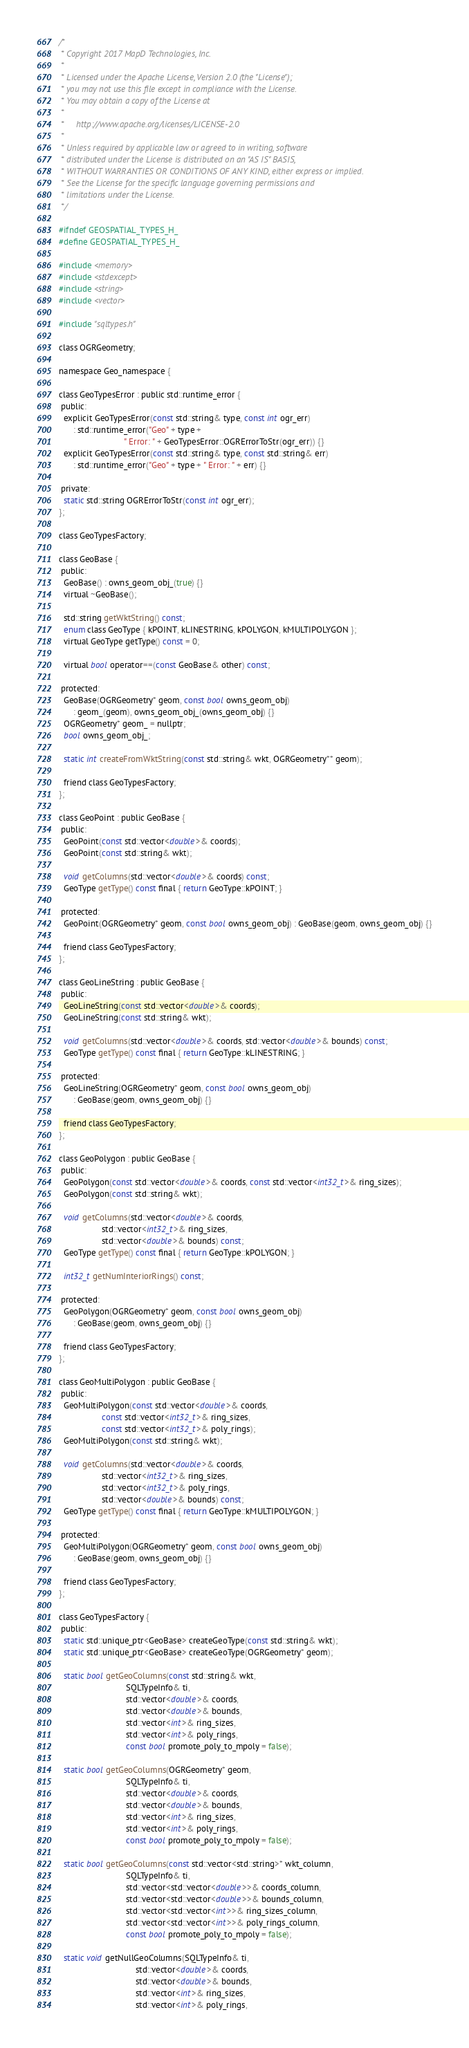<code> <loc_0><loc_0><loc_500><loc_500><_C_>/*
 * Copyright 2017 MapD Technologies, Inc.
 *
 * Licensed under the Apache License, Version 2.0 (the "License");
 * you may not use this file except in compliance with the License.
 * You may obtain a copy of the License at
 *
 *     http://www.apache.org/licenses/LICENSE-2.0
 *
 * Unless required by applicable law or agreed to in writing, software
 * distributed under the License is distributed on an "AS IS" BASIS,
 * WITHOUT WARRANTIES OR CONDITIONS OF ANY KIND, either express or implied.
 * See the License for the specific language governing permissions and
 * limitations under the License.
 */

#ifndef GEOSPATIAL_TYPES_H_
#define GEOSPATIAL_TYPES_H_

#include <memory>
#include <stdexcept>
#include <string>
#include <vector>

#include "sqltypes.h"

class OGRGeometry;

namespace Geo_namespace {

class GeoTypesError : public std::runtime_error {
 public:
  explicit GeoTypesError(const std::string& type, const int ogr_err)
      : std::runtime_error("Geo" + type +
                           " Error: " + GeoTypesError::OGRErrorToStr(ogr_err)) {}
  explicit GeoTypesError(const std::string& type, const std::string& err)
      : std::runtime_error("Geo" + type + " Error: " + err) {}

 private:
  static std::string OGRErrorToStr(const int ogr_err);
};

class GeoTypesFactory;

class GeoBase {
 public:
  GeoBase() : owns_geom_obj_(true) {}
  virtual ~GeoBase();

  std::string getWktString() const;
  enum class GeoType { kPOINT, kLINESTRING, kPOLYGON, kMULTIPOLYGON };
  virtual GeoType getType() const = 0;

  virtual bool operator==(const GeoBase& other) const;

 protected:
  GeoBase(OGRGeometry* geom, const bool owns_geom_obj)
      : geom_(geom), owns_geom_obj_(owns_geom_obj) {}
  OGRGeometry* geom_ = nullptr;
  bool owns_geom_obj_;

  static int createFromWktString(const std::string& wkt, OGRGeometry** geom);

  friend class GeoTypesFactory;
};

class GeoPoint : public GeoBase {
 public:
  GeoPoint(const std::vector<double>& coords);
  GeoPoint(const std::string& wkt);

  void getColumns(std::vector<double>& coords) const;
  GeoType getType() const final { return GeoType::kPOINT; }

 protected:
  GeoPoint(OGRGeometry* geom, const bool owns_geom_obj) : GeoBase(geom, owns_geom_obj) {}

  friend class GeoTypesFactory;
};

class GeoLineString : public GeoBase {
 public:
  GeoLineString(const std::vector<double>& coords);
  GeoLineString(const std::string& wkt);

  void getColumns(std::vector<double>& coords, std::vector<double>& bounds) const;
  GeoType getType() const final { return GeoType::kLINESTRING; }

 protected:
  GeoLineString(OGRGeometry* geom, const bool owns_geom_obj)
      : GeoBase(geom, owns_geom_obj) {}

  friend class GeoTypesFactory;
};

class GeoPolygon : public GeoBase {
 public:
  GeoPolygon(const std::vector<double>& coords, const std::vector<int32_t>& ring_sizes);
  GeoPolygon(const std::string& wkt);

  void getColumns(std::vector<double>& coords,
                  std::vector<int32_t>& ring_sizes,
                  std::vector<double>& bounds) const;
  GeoType getType() const final { return GeoType::kPOLYGON; }

  int32_t getNumInteriorRings() const;

 protected:
  GeoPolygon(OGRGeometry* geom, const bool owns_geom_obj)
      : GeoBase(geom, owns_geom_obj) {}

  friend class GeoTypesFactory;
};

class GeoMultiPolygon : public GeoBase {
 public:
  GeoMultiPolygon(const std::vector<double>& coords,
                  const std::vector<int32_t>& ring_sizes,
                  const std::vector<int32_t>& poly_rings);
  GeoMultiPolygon(const std::string& wkt);

  void getColumns(std::vector<double>& coords,
                  std::vector<int32_t>& ring_sizes,
                  std::vector<int32_t>& poly_rings,
                  std::vector<double>& bounds) const;
  GeoType getType() const final { return GeoType::kMULTIPOLYGON; }

 protected:
  GeoMultiPolygon(OGRGeometry* geom, const bool owns_geom_obj)
      : GeoBase(geom, owns_geom_obj) {}

  friend class GeoTypesFactory;
};

class GeoTypesFactory {
 public:
  static std::unique_ptr<GeoBase> createGeoType(const std::string& wkt);
  static std::unique_ptr<GeoBase> createGeoType(OGRGeometry* geom);

  static bool getGeoColumns(const std::string& wkt,
                            SQLTypeInfo& ti,
                            std::vector<double>& coords,
                            std::vector<double>& bounds,
                            std::vector<int>& ring_sizes,
                            std::vector<int>& poly_rings,
                            const bool promote_poly_to_mpoly = false);

  static bool getGeoColumns(OGRGeometry* geom,
                            SQLTypeInfo& ti,
                            std::vector<double>& coords,
                            std::vector<double>& bounds,
                            std::vector<int>& ring_sizes,
                            std::vector<int>& poly_rings,
                            const bool promote_poly_to_mpoly = false);

  static bool getGeoColumns(const std::vector<std::string>* wkt_column,
                            SQLTypeInfo& ti,
                            std::vector<std::vector<double>>& coords_column,
                            std::vector<std::vector<double>>& bounds_column,
                            std::vector<std::vector<int>>& ring_sizes_column,
                            std::vector<std::vector<int>>& poly_rings_column,
                            const bool promote_poly_to_mpoly = false);

  static void getNullGeoColumns(SQLTypeInfo& ti,
                                std::vector<double>& coords,
                                std::vector<double>& bounds,
                                std::vector<int>& ring_sizes,
                                std::vector<int>& poly_rings,</code> 